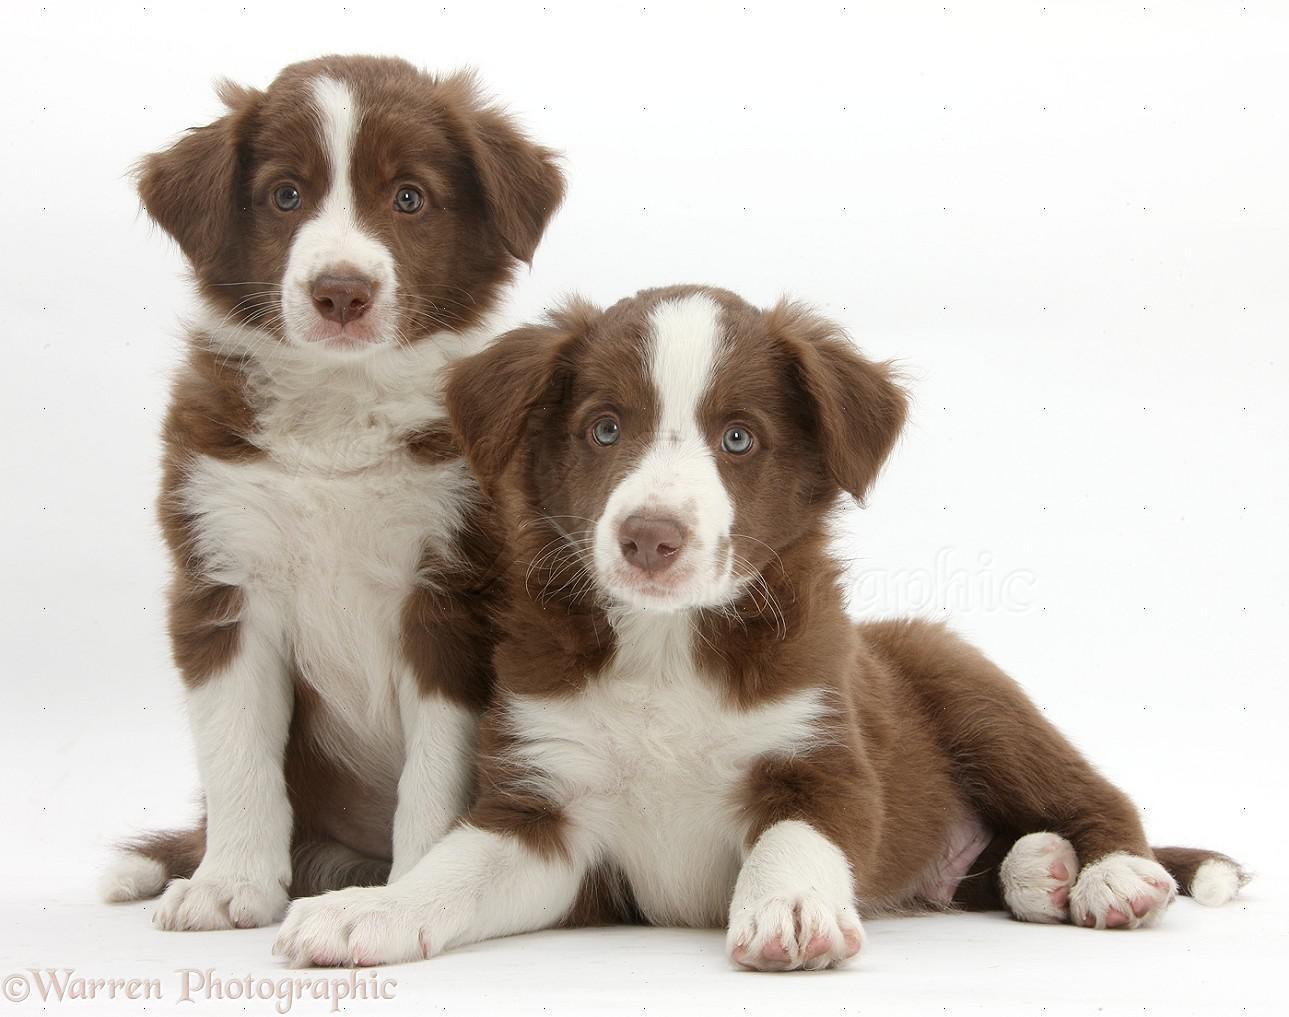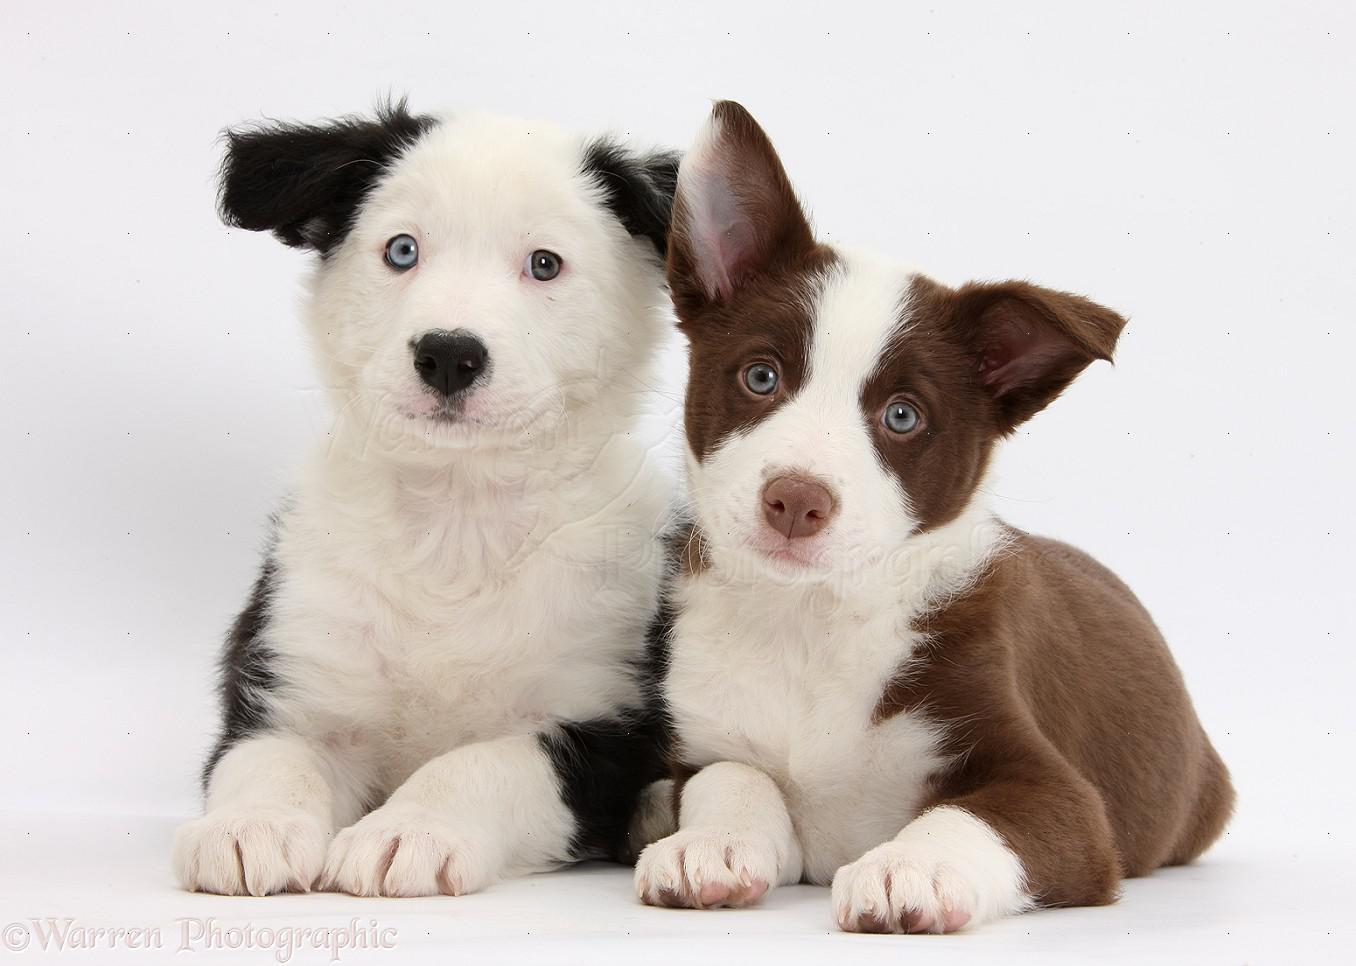The first image is the image on the left, the second image is the image on the right. Analyze the images presented: Is the assertion "Each image contains the same number of puppies, and all images have plain white backgrounds." valid? Answer yes or no. Yes. The first image is the image on the left, the second image is the image on the right. For the images shown, is this caption "No more than four dogs can be seen." true? Answer yes or no. Yes. 